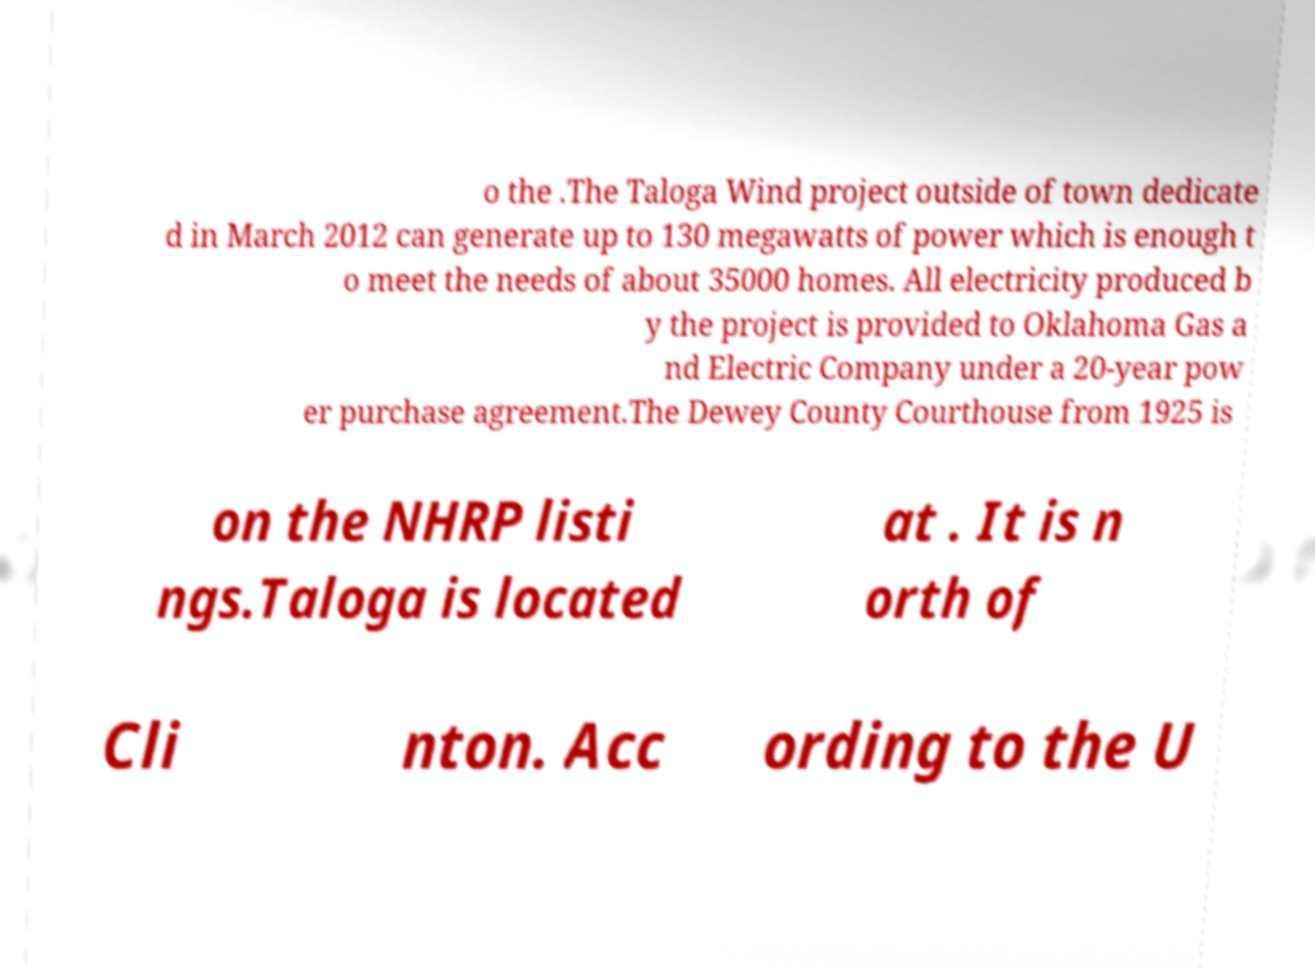For documentation purposes, I need the text within this image transcribed. Could you provide that? o the .The Taloga Wind project outside of town dedicate d in March 2012 can generate up to 130 megawatts of power which is enough t o meet the needs of about 35000 homes. All electricity produced b y the project is provided to Oklahoma Gas a nd Electric Company under a 20-year pow er purchase agreement.The Dewey County Courthouse from 1925 is on the NHRP listi ngs.Taloga is located at . It is n orth of Cli nton. Acc ording to the U 